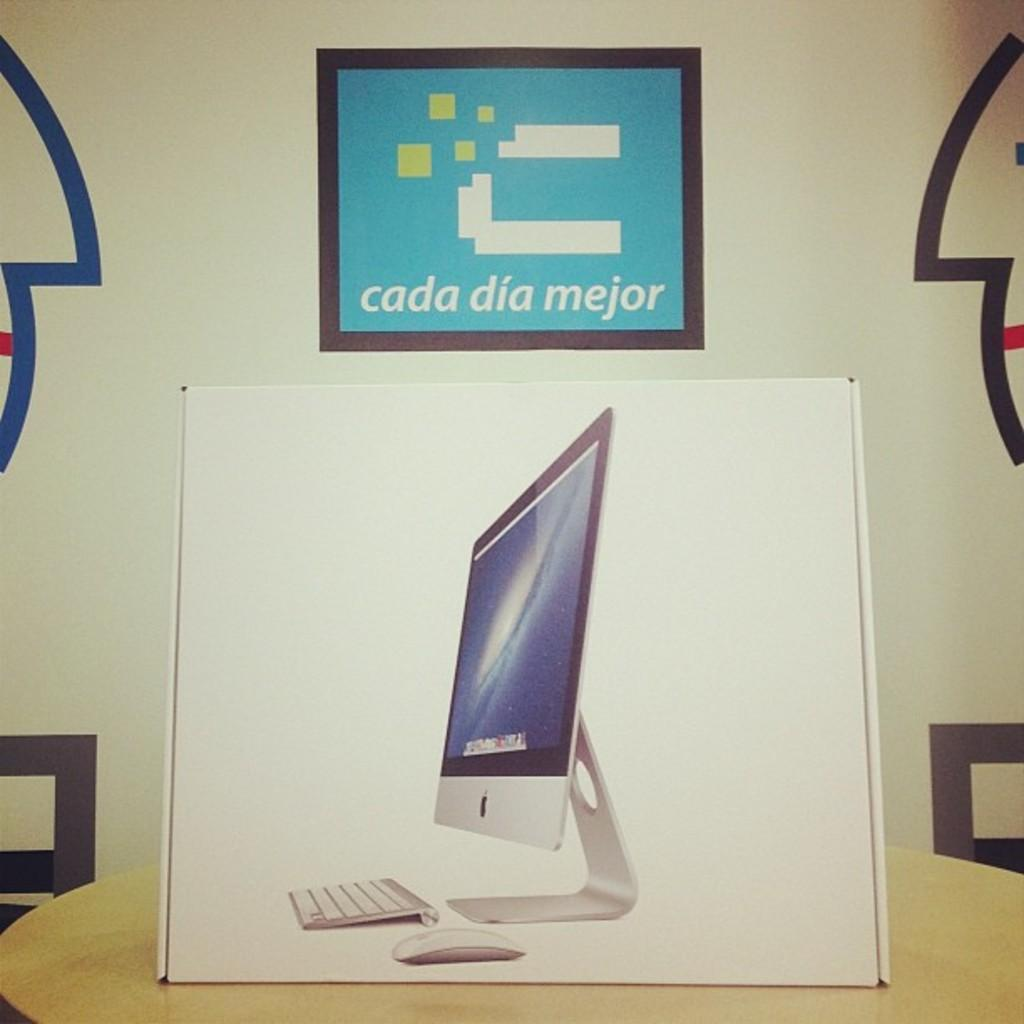<image>
Summarize the visual content of the image. A box containing a Mac computer sits under a sign that says "cada dia mejor". 